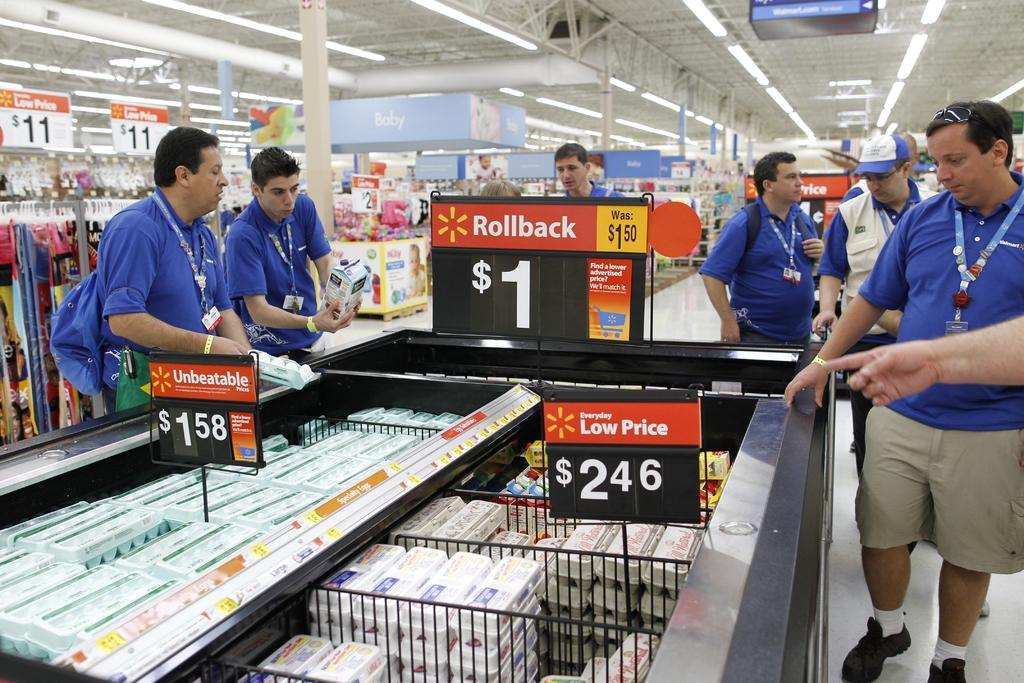<image>
Give a short and clear explanation of the subsequent image. A group of Walmart employees are looking at items under a $1 Rollback sign. 